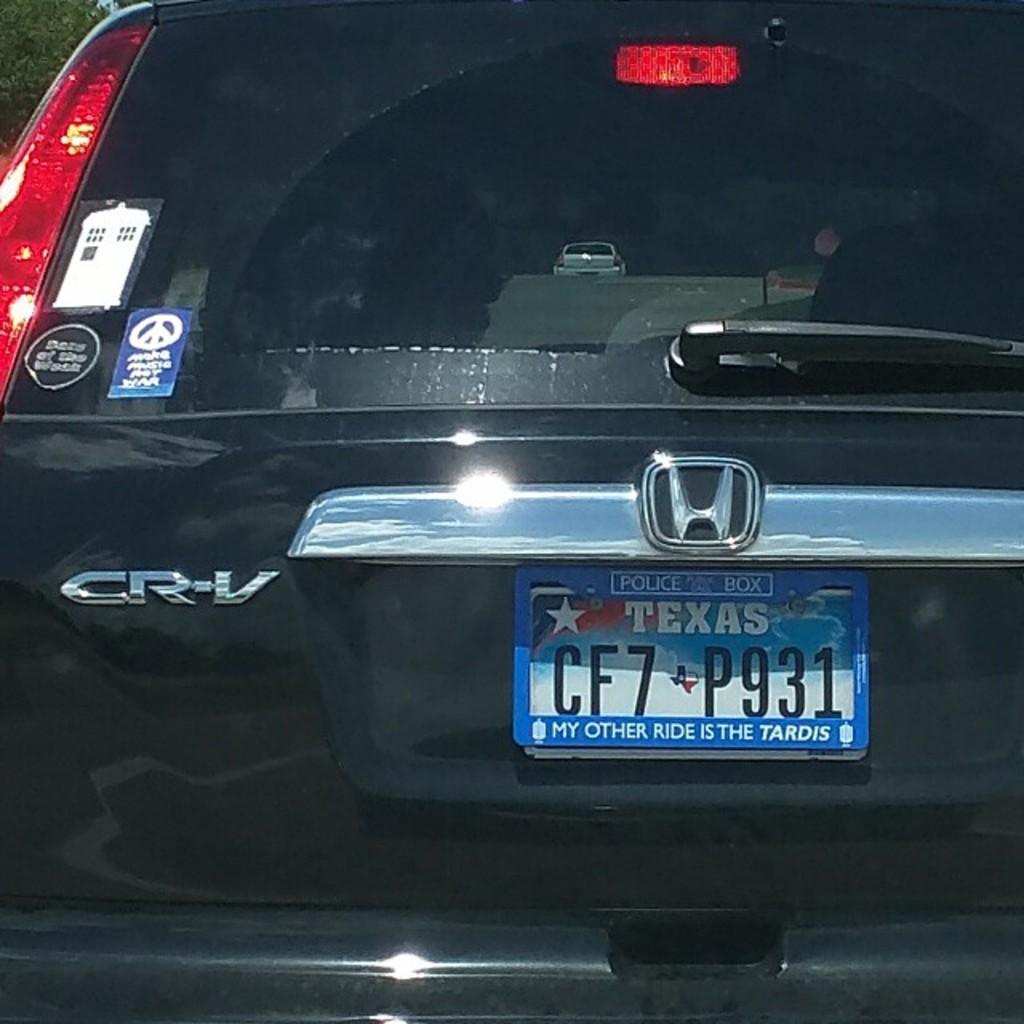<image>
Provide a brief description of the given image. A Texas license plate says "my other ride is the Tardis." 